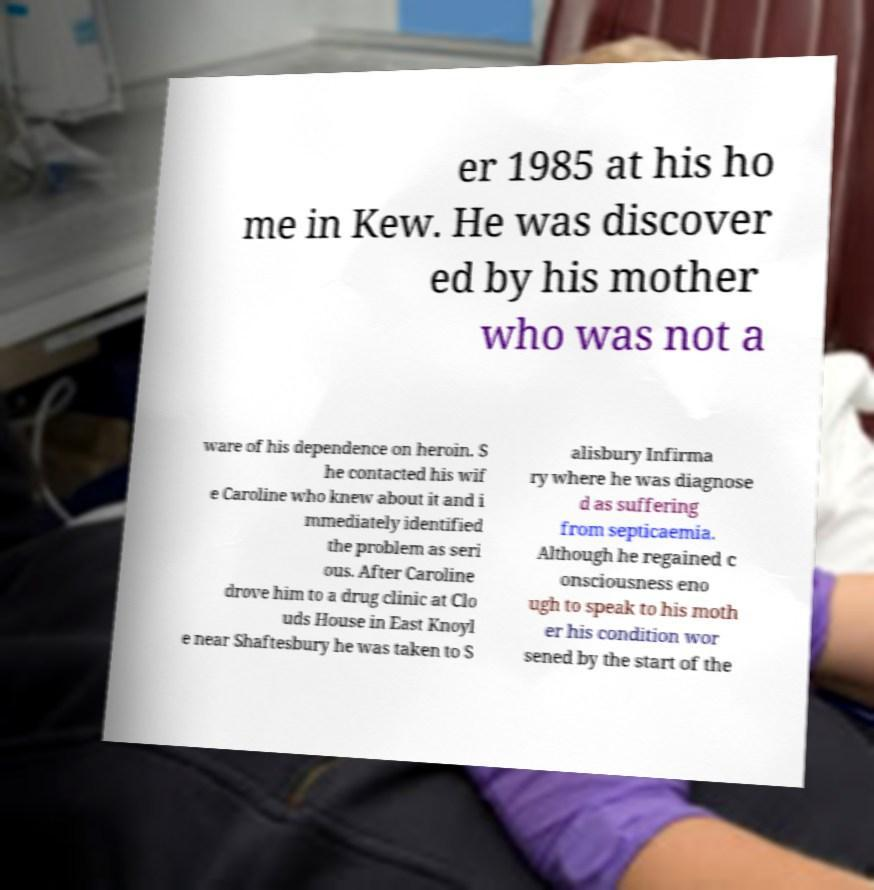Can you read and provide the text displayed in the image?This photo seems to have some interesting text. Can you extract and type it out for me? er 1985 at his ho me in Kew. He was discover ed by his mother who was not a ware of his dependence on heroin. S he contacted his wif e Caroline who knew about it and i mmediately identified the problem as seri ous. After Caroline drove him to a drug clinic at Clo uds House in East Knoyl e near Shaftesbury he was taken to S alisbury Infirma ry where he was diagnose d as suffering from septicaemia. Although he regained c onsciousness eno ugh to speak to his moth er his condition wor sened by the start of the 